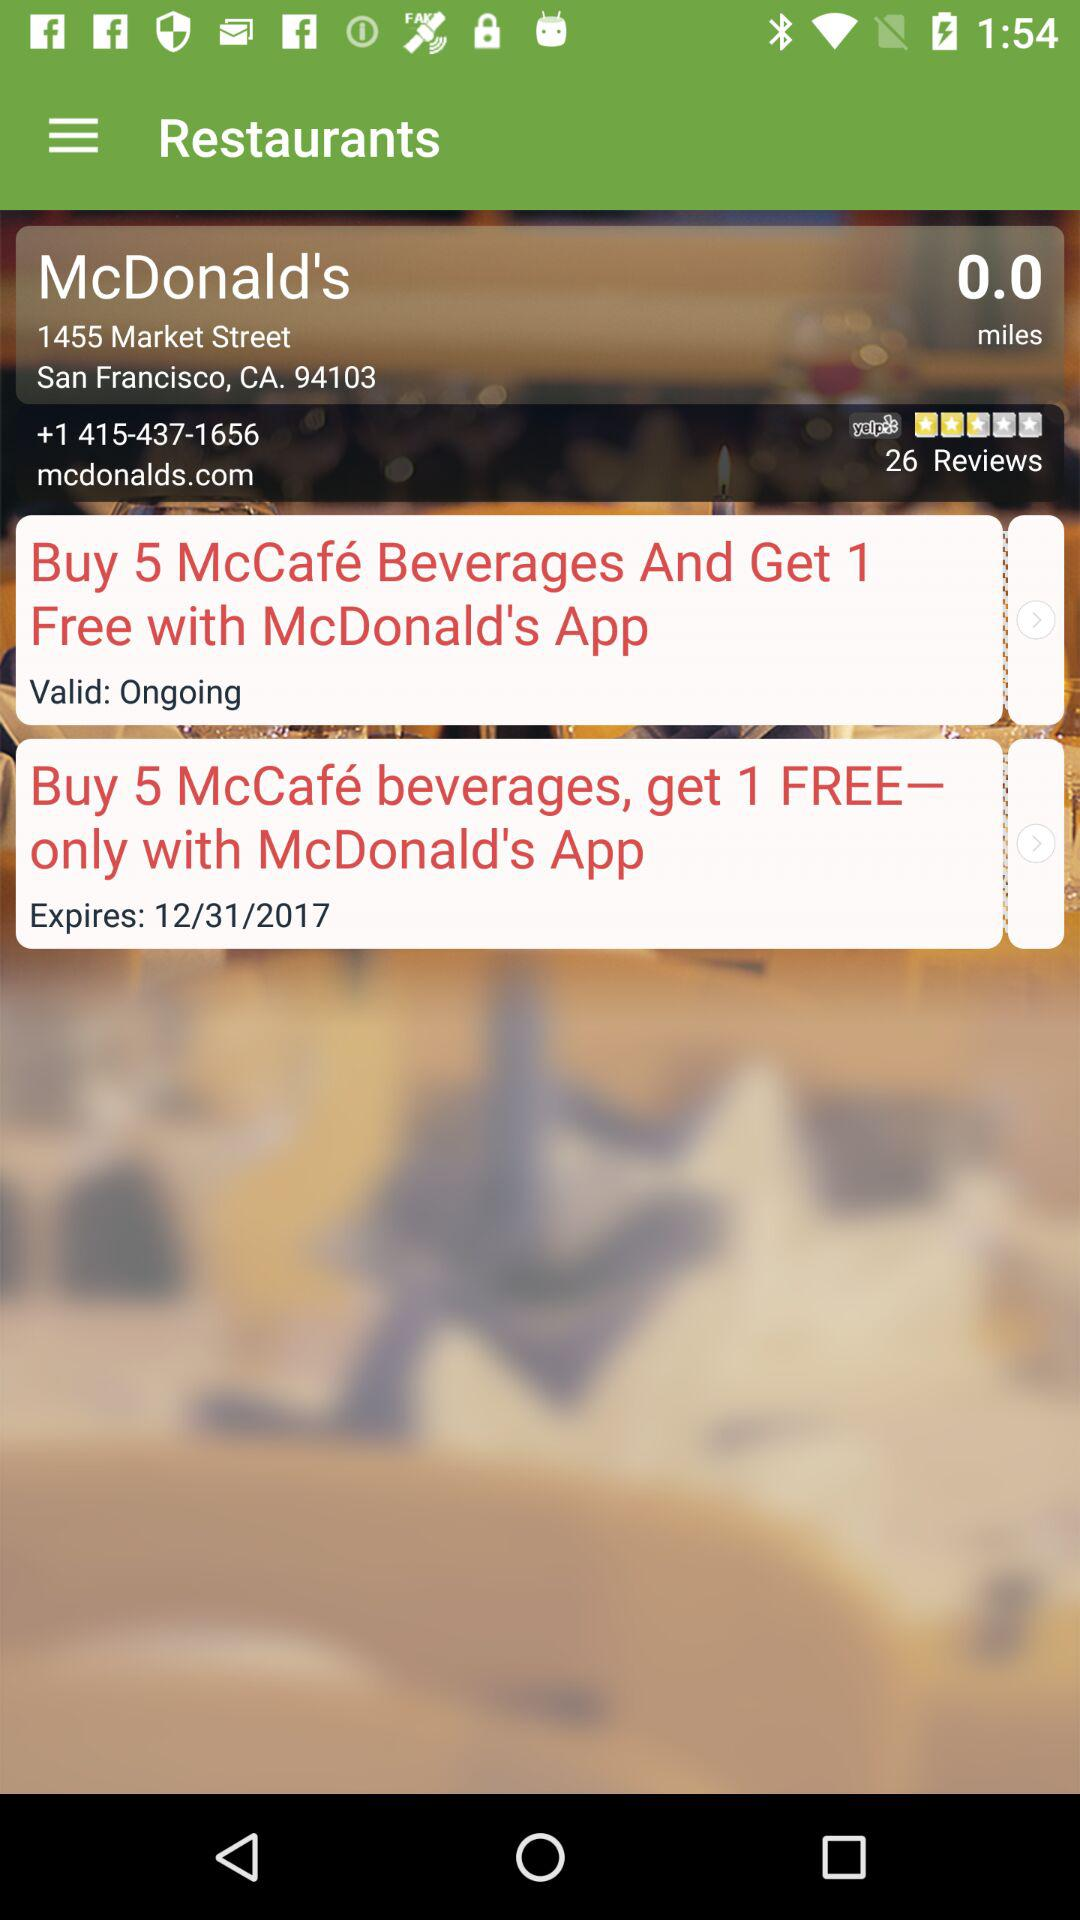When will the offer expire? The offer will expire on December 31, 2017. 